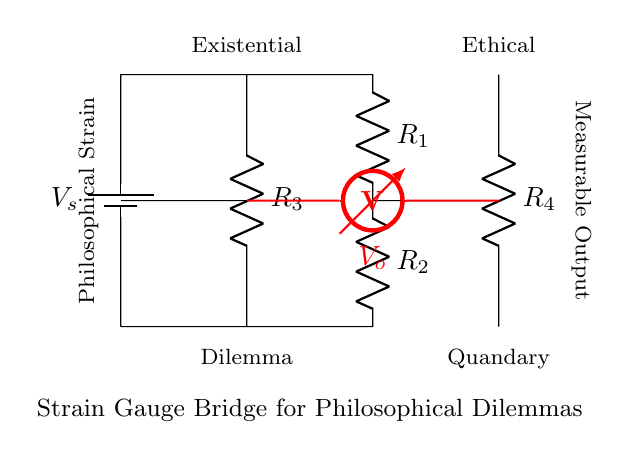What are the resistors labeled in the circuit? The circuit contains four resistors labeled R1, R2, R3, and R4, positioned at specific points. R1 and R2 are arranged in one branch of the bridge, while R3 and R4 are in the other.
Answer: R1, R2, R3, R4 What does the voltmeter measure in this circuit? The voltmeter, marked as Vo, measures the voltage difference between the two midpoints of the bridge formed by resistors R1, R2 and R3, R4. This indicates how the resistances affect the voltage output based on physical strain.
Answer: Voltage difference What is the configuration type of this circuit? The configuration of this circuit is a Wheatstone bridge, which is typically used to measure unknown electrical resistance by balancing two legs of a bridge circuit.
Answer: Wheatstone bridge How is the concept of strain applied in this circuit? The strain gauge bridge applies the philosophical metaphor of strain to physical dilemmas, indicating that it quantifies the 'strain' of ethical and existential dilemmas by measuring resistance changes due to physical deformation.
Answer: Philosophy and strain What would happen if R1 and R3 values are equal? If R1 and R3 are equal, the voltage measured by the voltmeter Vo would be zero, indicating a balanced bridge, where there is no net voltage change due to equal resistance.
Answer: Zero voltage 